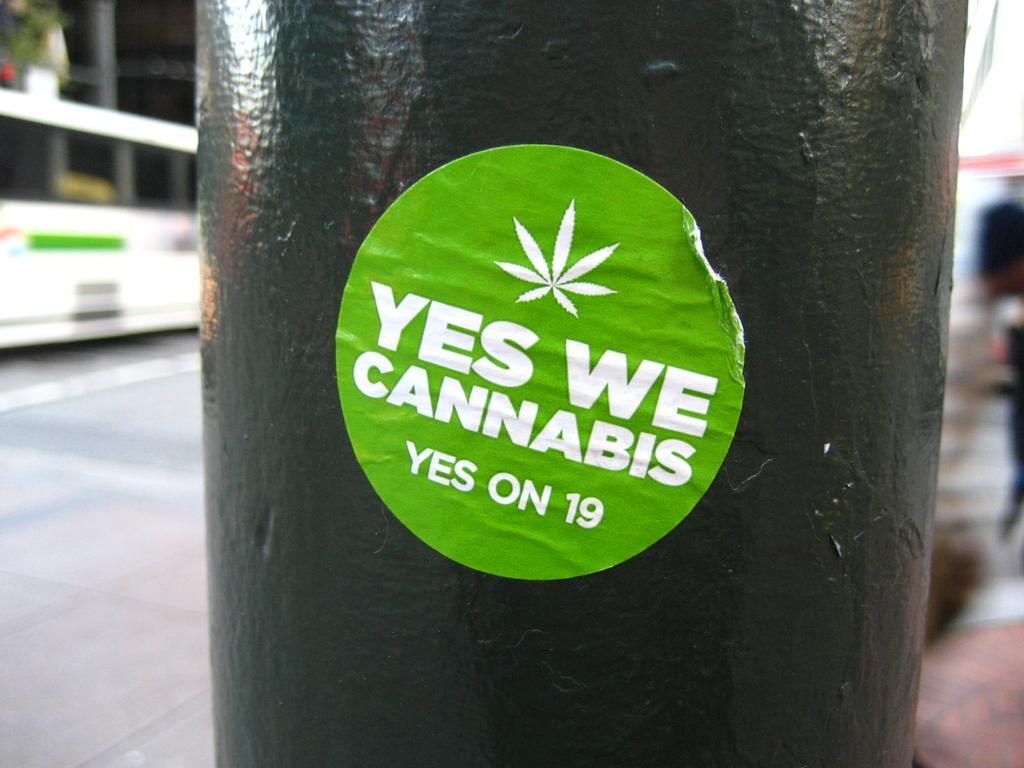How would you summarize this image in a sentence or two? This image is taken outdoors. On the left side of the image there is a road and a bus is parked on the road. In the middle of the image there is a pillar and there is a sticker with a text on the pillar. 